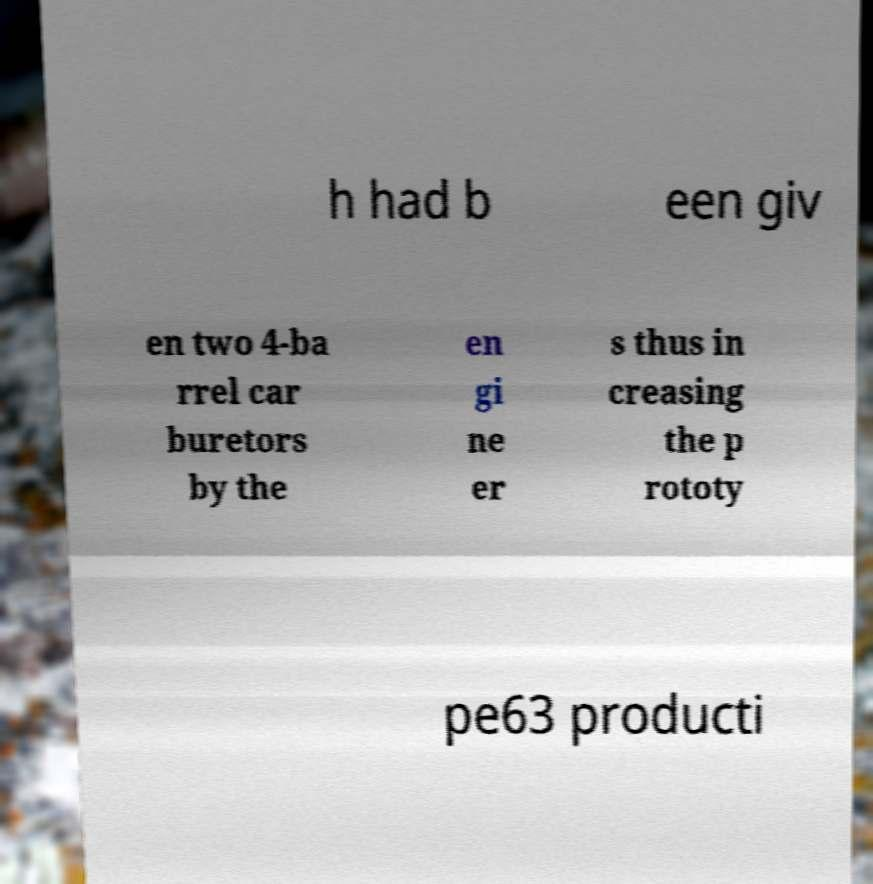For documentation purposes, I need the text within this image transcribed. Could you provide that? h had b een giv en two 4-ba rrel car buretors by the en gi ne er s thus in creasing the p rototy pe63 producti 